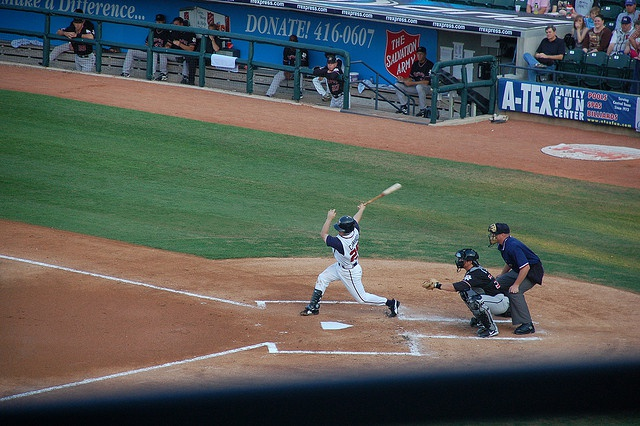Describe the objects in this image and their specific colors. I can see people in navy, lightblue, darkgray, and black tones, people in navy, black, gray, and blue tones, people in navy, black, gray, and darkgray tones, people in navy, black, gray, and blue tones, and people in navy, black, gray, and blue tones in this image. 